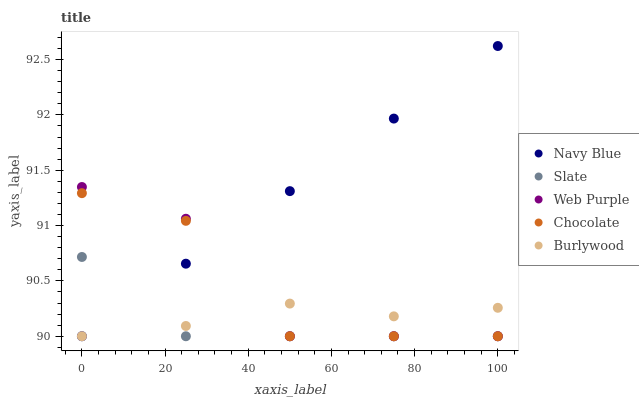Does Slate have the minimum area under the curve?
Answer yes or no. Yes. Does Navy Blue have the maximum area under the curve?
Answer yes or no. Yes. Does Navy Blue have the minimum area under the curve?
Answer yes or no. No. Does Slate have the maximum area under the curve?
Answer yes or no. No. Is Navy Blue the smoothest?
Answer yes or no. Yes. Is Web Purple the roughest?
Answer yes or no. Yes. Is Slate the smoothest?
Answer yes or no. No. Is Slate the roughest?
Answer yes or no. No. Does Burlywood have the lowest value?
Answer yes or no. Yes. Does Navy Blue have the highest value?
Answer yes or no. Yes. Does Slate have the highest value?
Answer yes or no. No. Does Burlywood intersect Slate?
Answer yes or no. Yes. Is Burlywood less than Slate?
Answer yes or no. No. Is Burlywood greater than Slate?
Answer yes or no. No. 